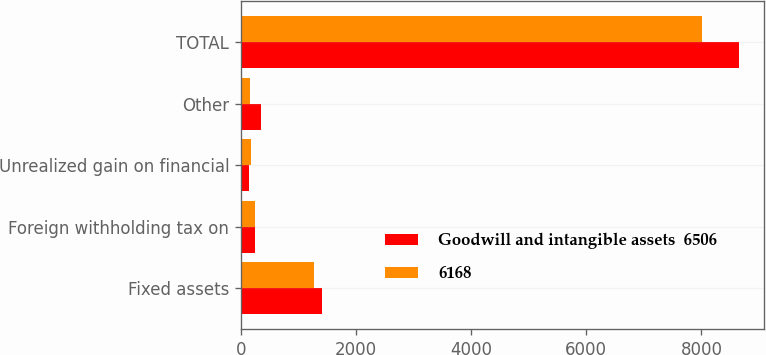Convert chart to OTSL. <chart><loc_0><loc_0><loc_500><loc_500><stacked_bar_chart><ecel><fcel>Fixed assets<fcel>Foreign withholding tax on<fcel>Unrealized gain on financial<fcel>Other<fcel>TOTAL<nl><fcel>Goodwill and intangible assets  6506<fcel>1413<fcel>239<fcel>147<fcel>351<fcel>8656<nl><fcel>6168<fcel>1276<fcel>244<fcel>169<fcel>161<fcel>8018<nl></chart> 